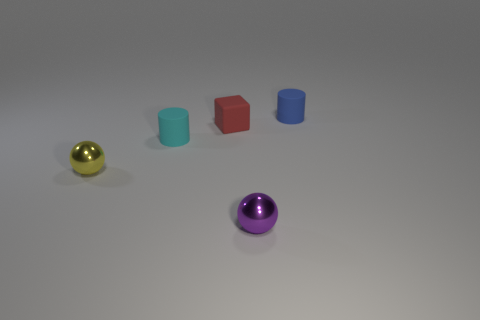Subtract all purple cylinders. Subtract all green cubes. How many cylinders are left? 2 Add 1 purple things. How many objects exist? 6 Subtract all cubes. How many objects are left? 4 Subtract 0 brown cubes. How many objects are left? 5 Subtract all metal objects. Subtract all cubes. How many objects are left? 2 Add 2 red rubber things. How many red rubber things are left? 3 Add 1 small metal objects. How many small metal objects exist? 3 